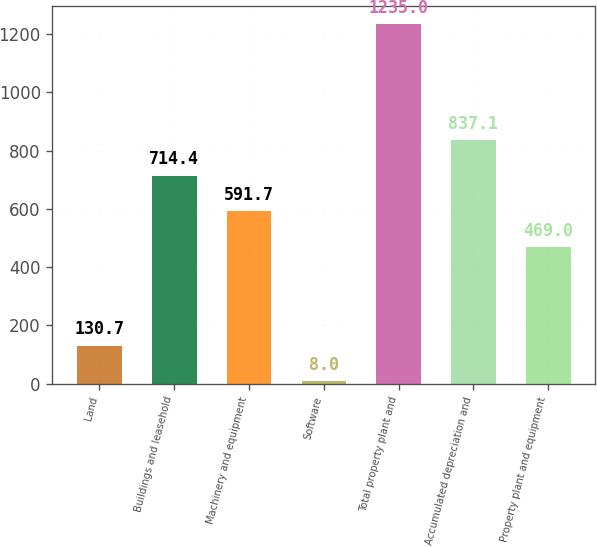<chart> <loc_0><loc_0><loc_500><loc_500><bar_chart><fcel>Land<fcel>Buildings and leasehold<fcel>Machinery and equipment<fcel>Software<fcel>Total property plant and<fcel>Accumulated depreciation and<fcel>Property plant and equipment<nl><fcel>130.7<fcel>714.4<fcel>591.7<fcel>8<fcel>1235<fcel>837.1<fcel>469<nl></chart> 